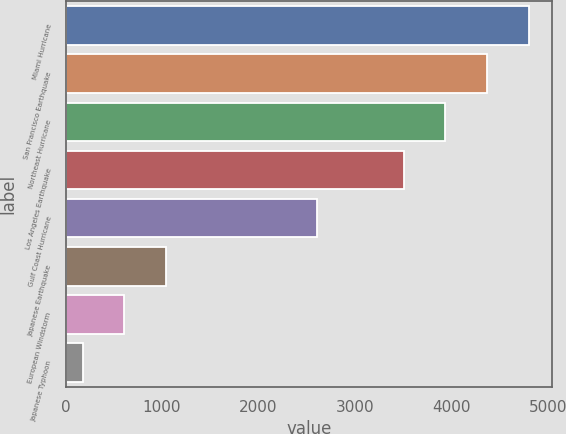<chart> <loc_0><loc_0><loc_500><loc_500><bar_chart><fcel>Miami Hurricane<fcel>San Francisco Earthquake<fcel>Northeast Hurricane<fcel>Los Angeles Earthquake<fcel>Gulf Coast Hurricane<fcel>Japanese Earthquake<fcel>European Windstorm<fcel>Japanese Typhoon<nl><fcel>4802.5<fcel>4371<fcel>3939.5<fcel>3508<fcel>2609<fcel>1041<fcel>609.5<fcel>178<nl></chart> 